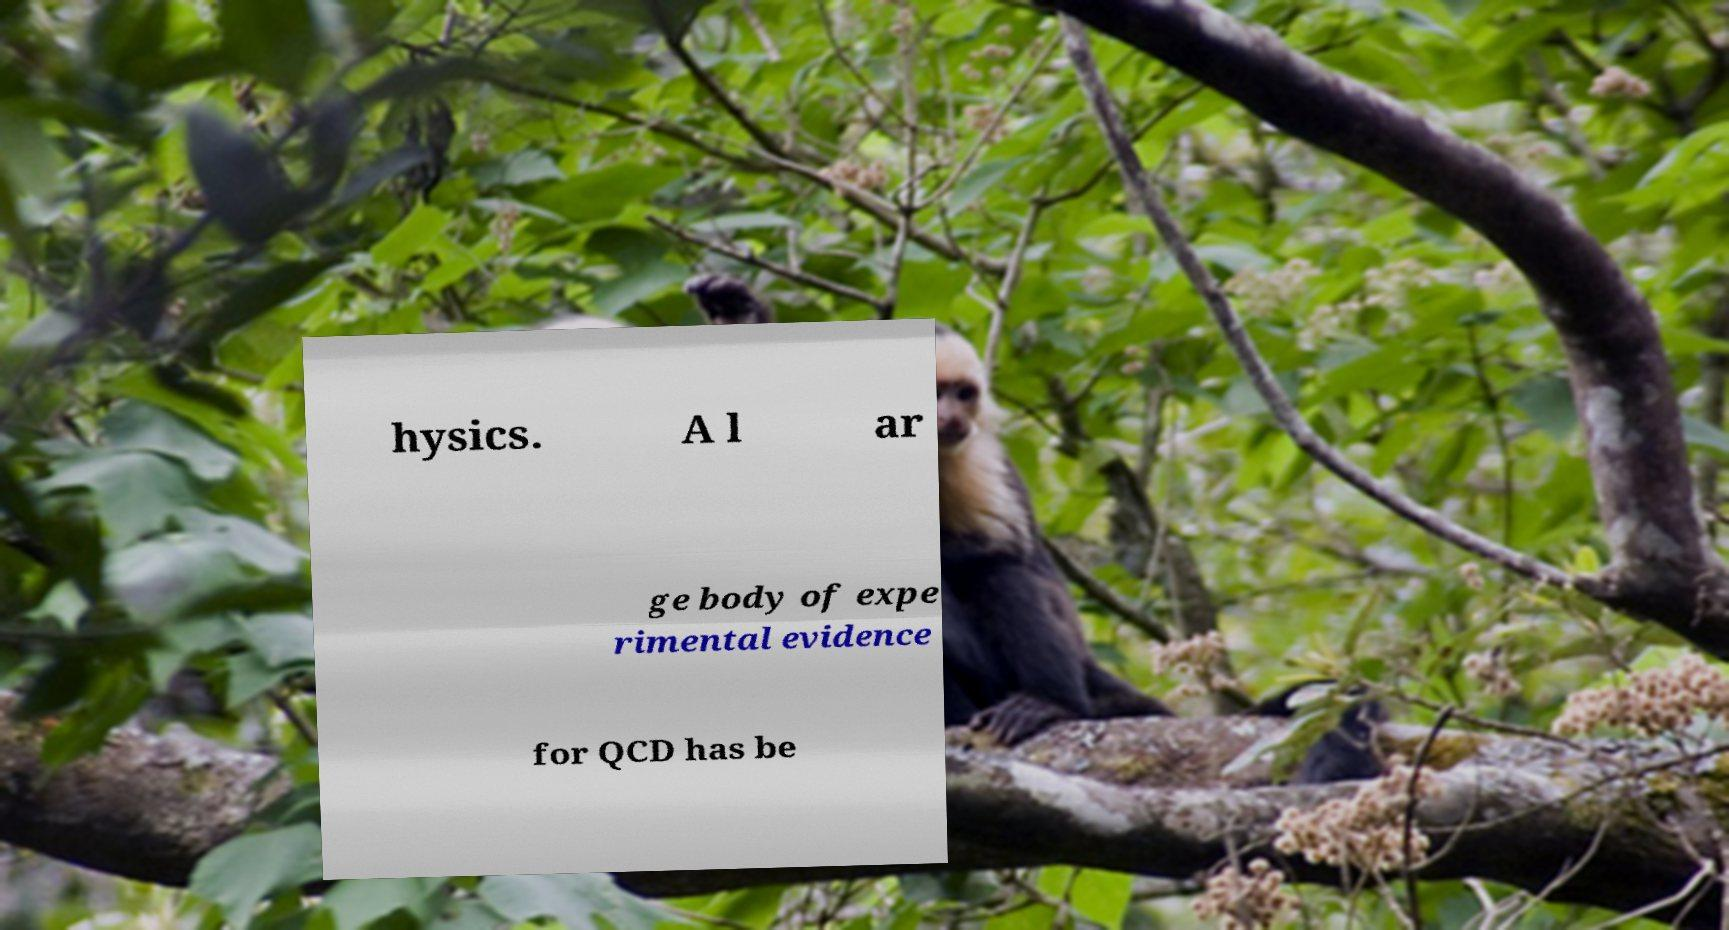Could you assist in decoding the text presented in this image and type it out clearly? hysics. A l ar ge body of expe rimental evidence for QCD has be 